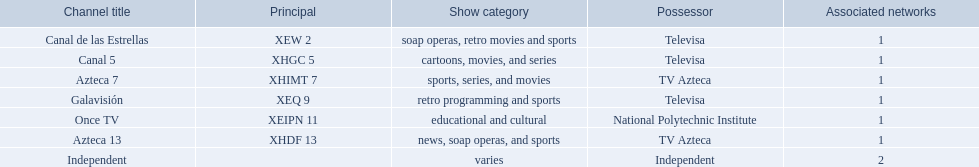What television stations are in morelos? Canal de las Estrellas, Canal 5, Azteca 7, Galavisión, Once TV, Azteca 13, Independent. Of those which network is owned by national polytechnic institute? Once TV. 